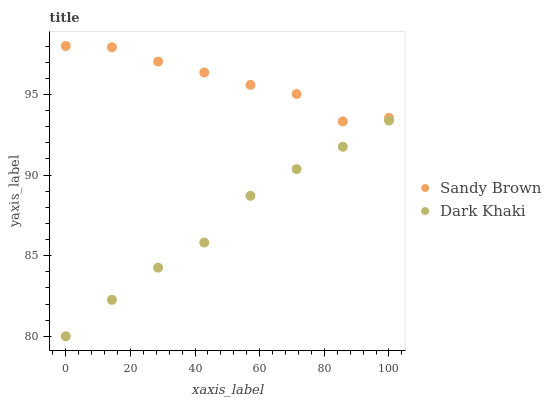Does Dark Khaki have the minimum area under the curve?
Answer yes or no. Yes. Does Sandy Brown have the maximum area under the curve?
Answer yes or no. Yes. Does Sandy Brown have the minimum area under the curve?
Answer yes or no. No. Is Dark Khaki the smoothest?
Answer yes or no. Yes. Is Sandy Brown the roughest?
Answer yes or no. Yes. Is Sandy Brown the smoothest?
Answer yes or no. No. Does Dark Khaki have the lowest value?
Answer yes or no. Yes. Does Sandy Brown have the lowest value?
Answer yes or no. No. Does Sandy Brown have the highest value?
Answer yes or no. Yes. Is Dark Khaki less than Sandy Brown?
Answer yes or no. Yes. Is Sandy Brown greater than Dark Khaki?
Answer yes or no. Yes. Does Dark Khaki intersect Sandy Brown?
Answer yes or no. No. 